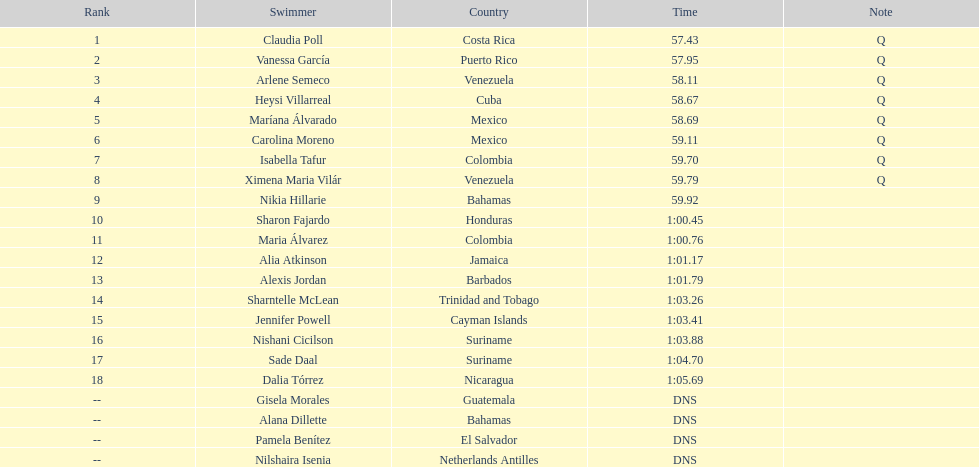How many swimmers recorded a minimum time of 1:00? 9. 